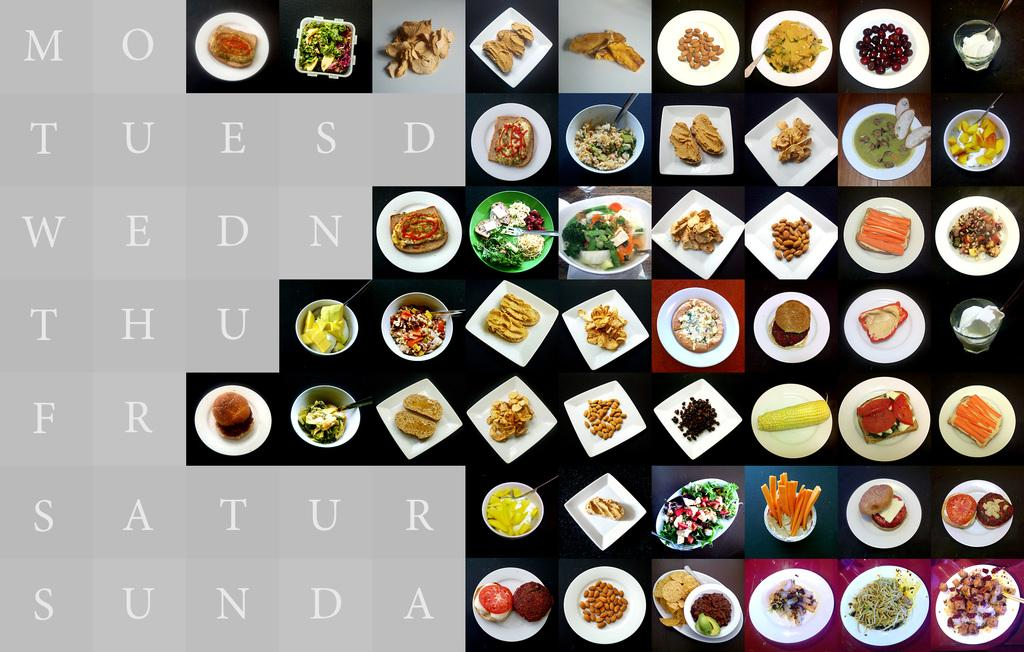What is featured on the poster in the image? There is a poster in the image that contains plates, bowls, food, and alphabets. What type of items can be seen on the poster? The poster contains plates, bowls, and food. What else is present on the poster besides the food items? The poster also contains alphabets. Where is the pocket located on the poster? There is no pocket present on the poster; it only contains plates, bowls, food, and alphabets. What type of animal can be seen grazing on the food in the image? There is no animal, such as a zebra, present in the image. 